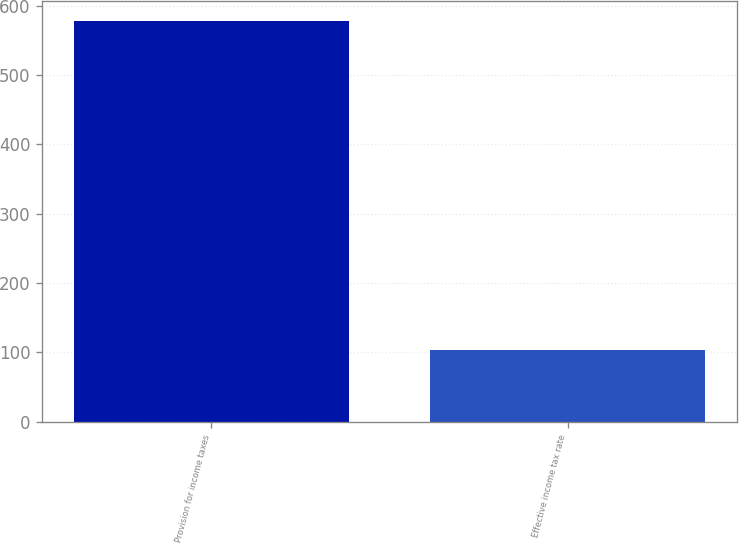Convert chart. <chart><loc_0><loc_0><loc_500><loc_500><bar_chart><fcel>Provision for income taxes<fcel>Effective income tax rate<nl><fcel>578<fcel>103.4<nl></chart> 